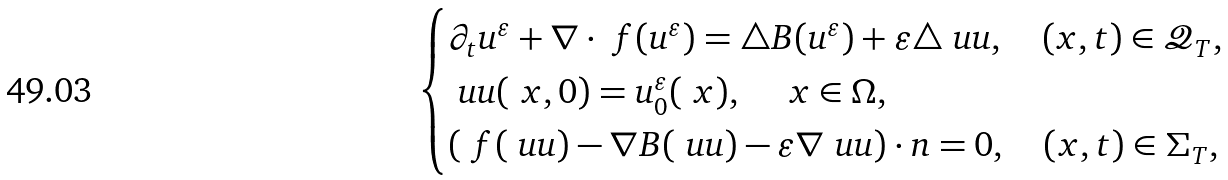<formula> <loc_0><loc_0><loc_500><loc_500>\begin{cases} \partial _ { t } u ^ { \varepsilon } + \nabla \cdot \ f ( u ^ { \varepsilon } ) = \triangle B ( u ^ { \varepsilon } ) + \varepsilon \triangle \ u u , \quad ( { x } , t ) \in \mathcal { Q } _ { T } , \\ \ u u ( \ x , 0 ) = u _ { 0 } ^ { \varepsilon } ( \ x ) , \quad \ x \in \Omega , \\ ( \ f ( \ u u ) - \nabla B ( \ u u ) - \varepsilon \nabla \ u u ) \cdot n = 0 , \quad ( { x } , t ) \in \Sigma _ { T } , \end{cases}</formula> 